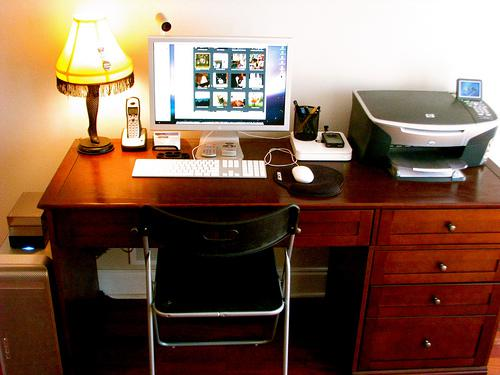Question: how many drawers are there in the desk?
Choices:
A. Five.
B. Six.
C. Four.
D. Seven.
Answer with the letter. Answer: A Question: what is on the right of the desk?
Choices:
A. A telephone.
B. An adding machine.
C. A printer.
D. A computer.
Answer with the letter. Answer: C 